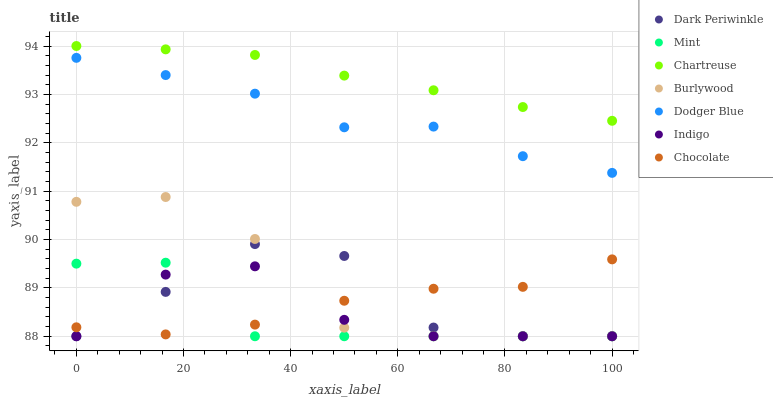Does Mint have the minimum area under the curve?
Answer yes or no. Yes. Does Chartreuse have the maximum area under the curve?
Answer yes or no. Yes. Does Burlywood have the minimum area under the curve?
Answer yes or no. No. Does Burlywood have the maximum area under the curve?
Answer yes or no. No. Is Chartreuse the smoothest?
Answer yes or no. Yes. Is Dark Periwinkle the roughest?
Answer yes or no. Yes. Is Burlywood the smoothest?
Answer yes or no. No. Is Burlywood the roughest?
Answer yes or no. No. Does Indigo have the lowest value?
Answer yes or no. Yes. Does Chocolate have the lowest value?
Answer yes or no. No. Does Chartreuse have the highest value?
Answer yes or no. Yes. Does Burlywood have the highest value?
Answer yes or no. No. Is Dark Periwinkle less than Chartreuse?
Answer yes or no. Yes. Is Dodger Blue greater than Dark Periwinkle?
Answer yes or no. Yes. Does Burlywood intersect Chocolate?
Answer yes or no. Yes. Is Burlywood less than Chocolate?
Answer yes or no. No. Is Burlywood greater than Chocolate?
Answer yes or no. No. Does Dark Periwinkle intersect Chartreuse?
Answer yes or no. No. 